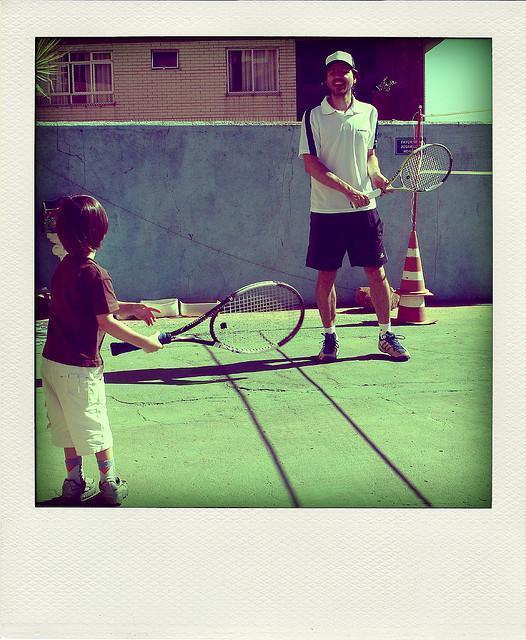How many tennis rackets are in the photo?
Give a very brief answer. 2. How many people are visible?
Give a very brief answer. 2. How many zebras in the picture?
Give a very brief answer. 0. 